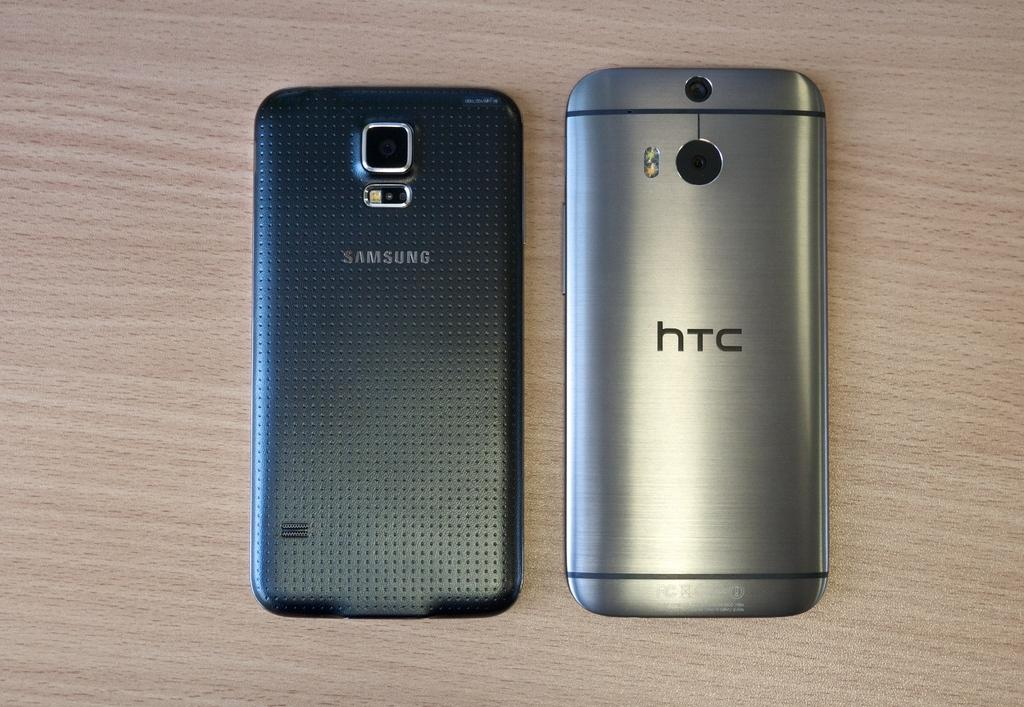How many mobile phones are visible in the image? There are two mobile phones in the image. What is the surface on which the mobile phones are placed? The mobile phones are on a wooden surface. What degree of difficulty is the volleyball game being played in the image? There is no volleyball game present in the image; it only features two mobile phones on a wooden surface. 